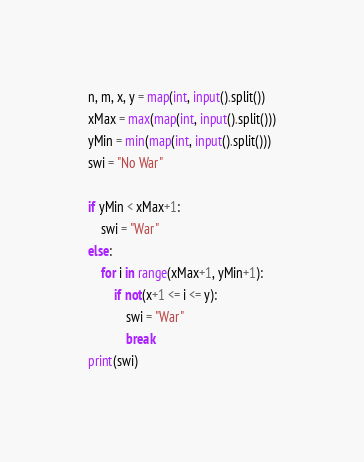Convert code to text. <code><loc_0><loc_0><loc_500><loc_500><_Python_>n, m, x, y = map(int, input().split())
xMax = max(map(int, input().split()))
yMin = min(map(int, input().split()))
swi = "No War"

if yMin < xMax+1:
    swi = "War"
else:
    for i in range(xMax+1, yMin+1):
        if not(x+1 <= i <= y):
            swi = "War"
            break
print(swi)
</code> 